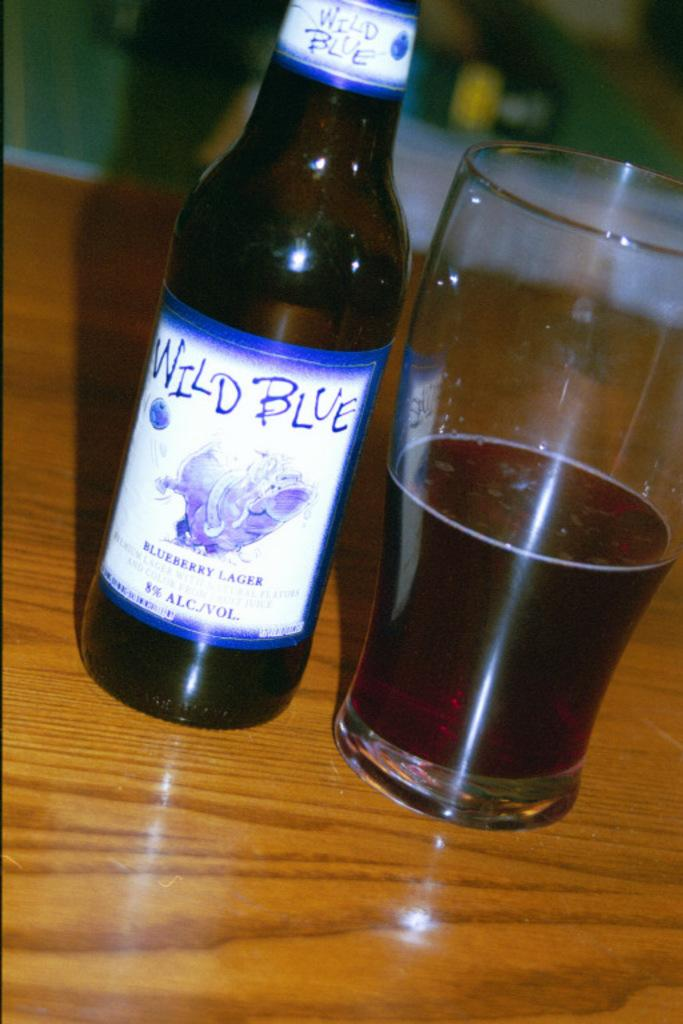<image>
Present a compact description of the photo's key features. A bottle of Wild Blue sits poured into a glass 